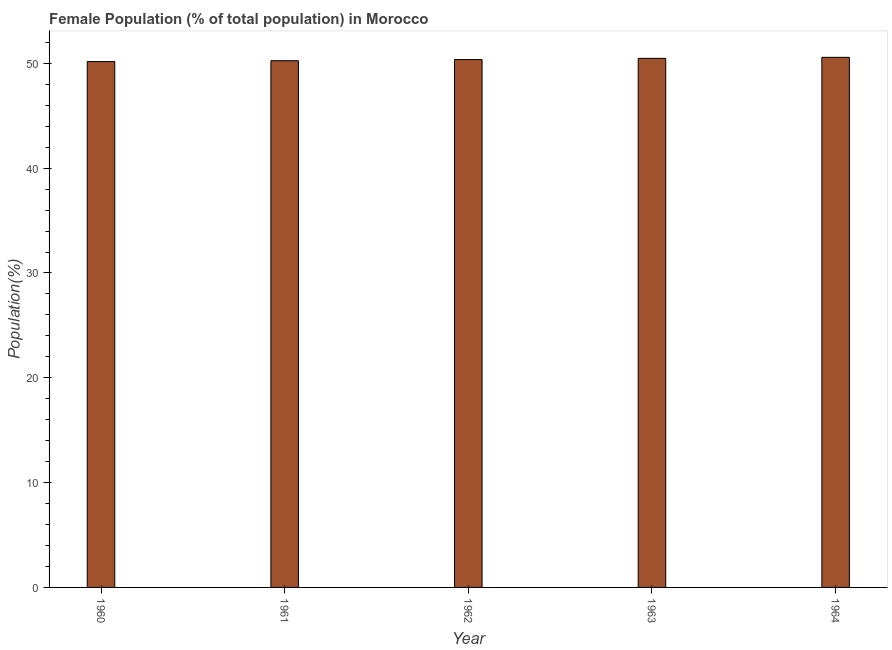What is the title of the graph?
Provide a succinct answer. Female Population (% of total population) in Morocco. What is the label or title of the Y-axis?
Offer a terse response. Population(%). What is the female population in 1960?
Your answer should be very brief. 50.17. Across all years, what is the maximum female population?
Keep it short and to the point. 50.57. Across all years, what is the minimum female population?
Offer a terse response. 50.17. In which year was the female population maximum?
Ensure brevity in your answer.  1964. In which year was the female population minimum?
Keep it short and to the point. 1960. What is the sum of the female population?
Make the answer very short. 251.84. What is the difference between the female population in 1960 and 1962?
Your response must be concise. -0.19. What is the average female population per year?
Your answer should be compact. 50.37. What is the median female population?
Your answer should be compact. 50.36. In how many years, is the female population greater than 38 %?
Provide a succinct answer. 5. Do a majority of the years between 1961 and 1963 (inclusive) have female population greater than 18 %?
Give a very brief answer. Yes. What is the ratio of the female population in 1962 to that in 1964?
Your answer should be compact. 1. Is the female population in 1961 less than that in 1964?
Your response must be concise. Yes. Is the difference between the female population in 1960 and 1962 greater than the difference between any two years?
Ensure brevity in your answer.  No. What is the difference between the highest and the second highest female population?
Provide a succinct answer. 0.1. What is the difference between the highest and the lowest female population?
Make the answer very short. 0.4. What is the difference between two consecutive major ticks on the Y-axis?
Provide a succinct answer. 10. What is the Population(%) in 1960?
Provide a succinct answer. 50.17. What is the Population(%) of 1961?
Offer a very short reply. 50.25. What is the Population(%) in 1962?
Give a very brief answer. 50.36. What is the Population(%) in 1963?
Your response must be concise. 50.48. What is the Population(%) of 1964?
Provide a succinct answer. 50.57. What is the difference between the Population(%) in 1960 and 1961?
Provide a short and direct response. -0.08. What is the difference between the Population(%) in 1960 and 1962?
Your answer should be compact. -0.19. What is the difference between the Population(%) in 1960 and 1963?
Your answer should be compact. -0.3. What is the difference between the Population(%) in 1960 and 1964?
Provide a short and direct response. -0.4. What is the difference between the Population(%) in 1961 and 1962?
Provide a succinct answer. -0.11. What is the difference between the Population(%) in 1961 and 1963?
Ensure brevity in your answer.  -0.22. What is the difference between the Population(%) in 1961 and 1964?
Your answer should be very brief. -0.32. What is the difference between the Population(%) in 1962 and 1963?
Keep it short and to the point. -0.12. What is the difference between the Population(%) in 1962 and 1964?
Provide a short and direct response. -0.21. What is the difference between the Population(%) in 1963 and 1964?
Give a very brief answer. -0.1. What is the ratio of the Population(%) in 1960 to that in 1961?
Your answer should be very brief. 1. What is the ratio of the Population(%) in 1960 to that in 1963?
Make the answer very short. 0.99. What is the ratio of the Population(%) in 1961 to that in 1963?
Your response must be concise. 1. What is the ratio of the Population(%) in 1962 to that in 1964?
Keep it short and to the point. 1. What is the ratio of the Population(%) in 1963 to that in 1964?
Ensure brevity in your answer.  1. 